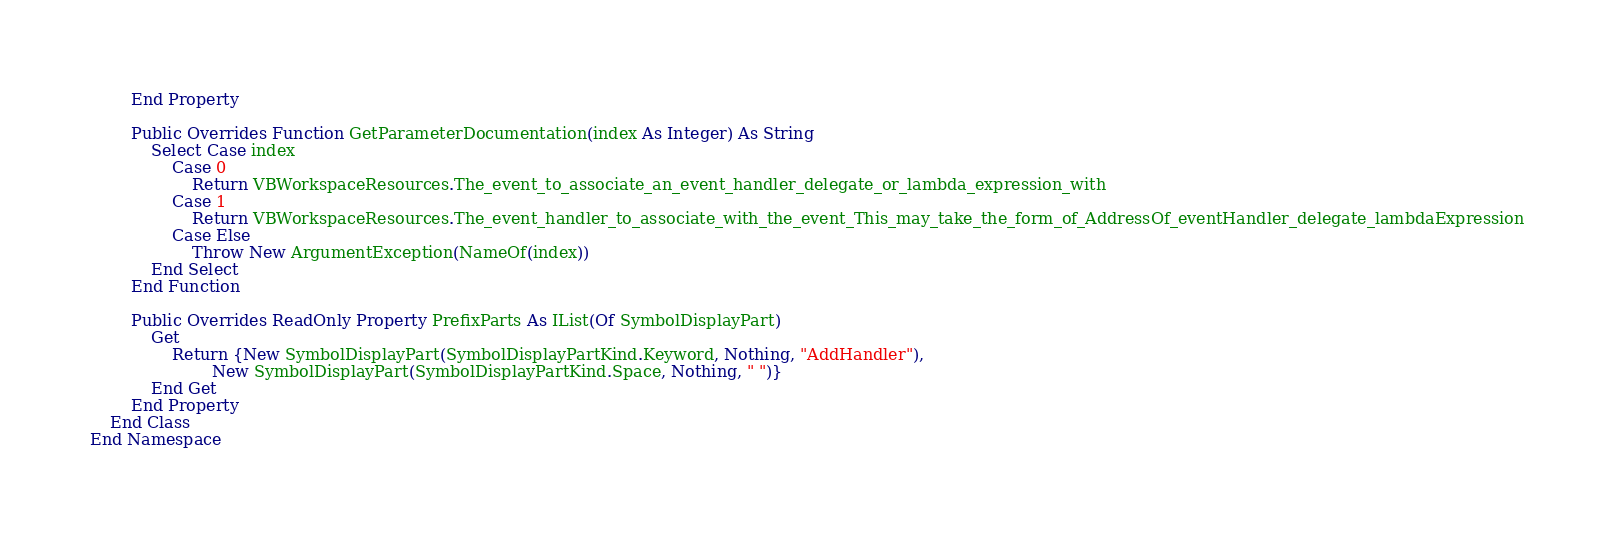Convert code to text. <code><loc_0><loc_0><loc_500><loc_500><_VisualBasic_>        End Property

        Public Overrides Function GetParameterDocumentation(index As Integer) As String
            Select Case index
                Case 0
                    Return VBWorkspaceResources.The_event_to_associate_an_event_handler_delegate_or_lambda_expression_with
                Case 1
                    Return VBWorkspaceResources.The_event_handler_to_associate_with_the_event_This_may_take_the_form_of_AddressOf_eventHandler_delegate_lambdaExpression
                Case Else
                    Throw New ArgumentException(NameOf(index))
            End Select
        End Function

        Public Overrides ReadOnly Property PrefixParts As IList(Of SymbolDisplayPart)
            Get
                Return {New SymbolDisplayPart(SymbolDisplayPartKind.Keyword, Nothing, "AddHandler"),
                        New SymbolDisplayPart(SymbolDisplayPartKind.Space, Nothing, " ")}
            End Get
        End Property
    End Class
End Namespace

</code> 